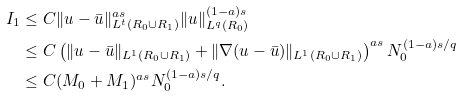Convert formula to latex. <formula><loc_0><loc_0><loc_500><loc_500>I _ { 1 } & \leq C \| u - \bar { u } \| _ { L ^ { t } ( R _ { 0 } \cup R _ { 1 } ) } ^ { a s } \| u \| _ { L ^ { q } ( R _ { 0 } ) } ^ { ( 1 - a ) s } \\ & \leq C \left ( \| u - \bar { u } \| _ { L ^ { 1 } ( R _ { 0 } \cup R _ { 1 } ) } + \| \nabla ( u - \bar { u } ) \| _ { L ^ { 1 } ( R _ { 0 } \cup R _ { 1 } ) } \right ) ^ { a s } N _ { 0 } ^ { ( 1 - a ) s / q } \\ & \leq C ( M _ { 0 } + M _ { 1 } ) ^ { a s } N _ { 0 } ^ { ( 1 - a ) s / q } .</formula> 